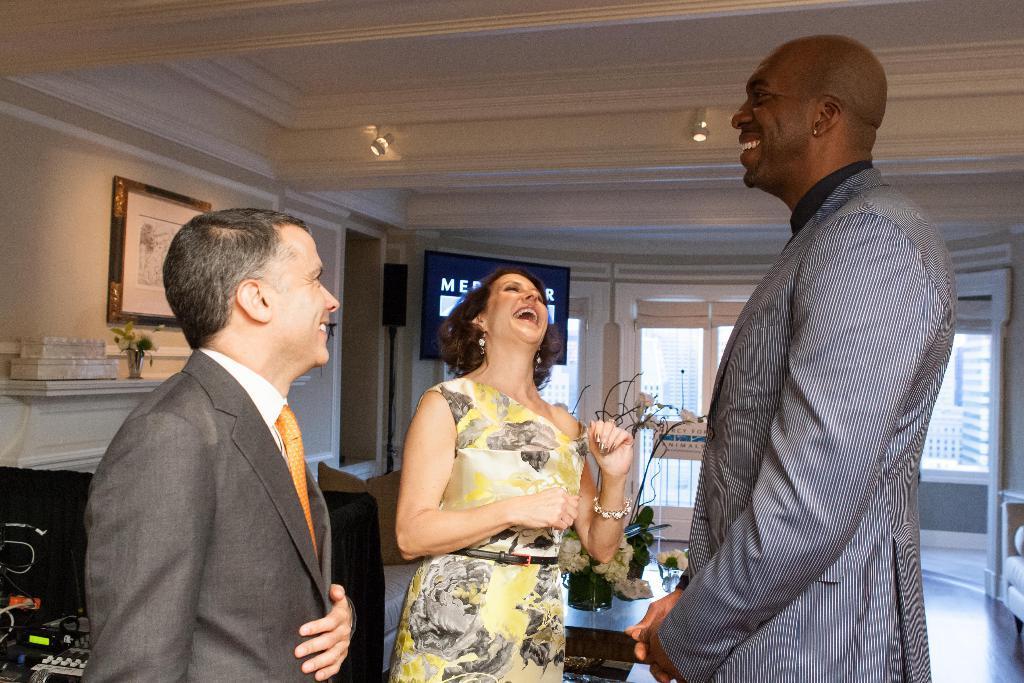Describe this image in one or two sentences. In this picture I can see few people standing and I can see smile on their faces and couple of flower pots on the table and a television on the back and I can see a photo frame on the wall and couple of lights to the ceiling and from the glass Windows I can see other buildings. 